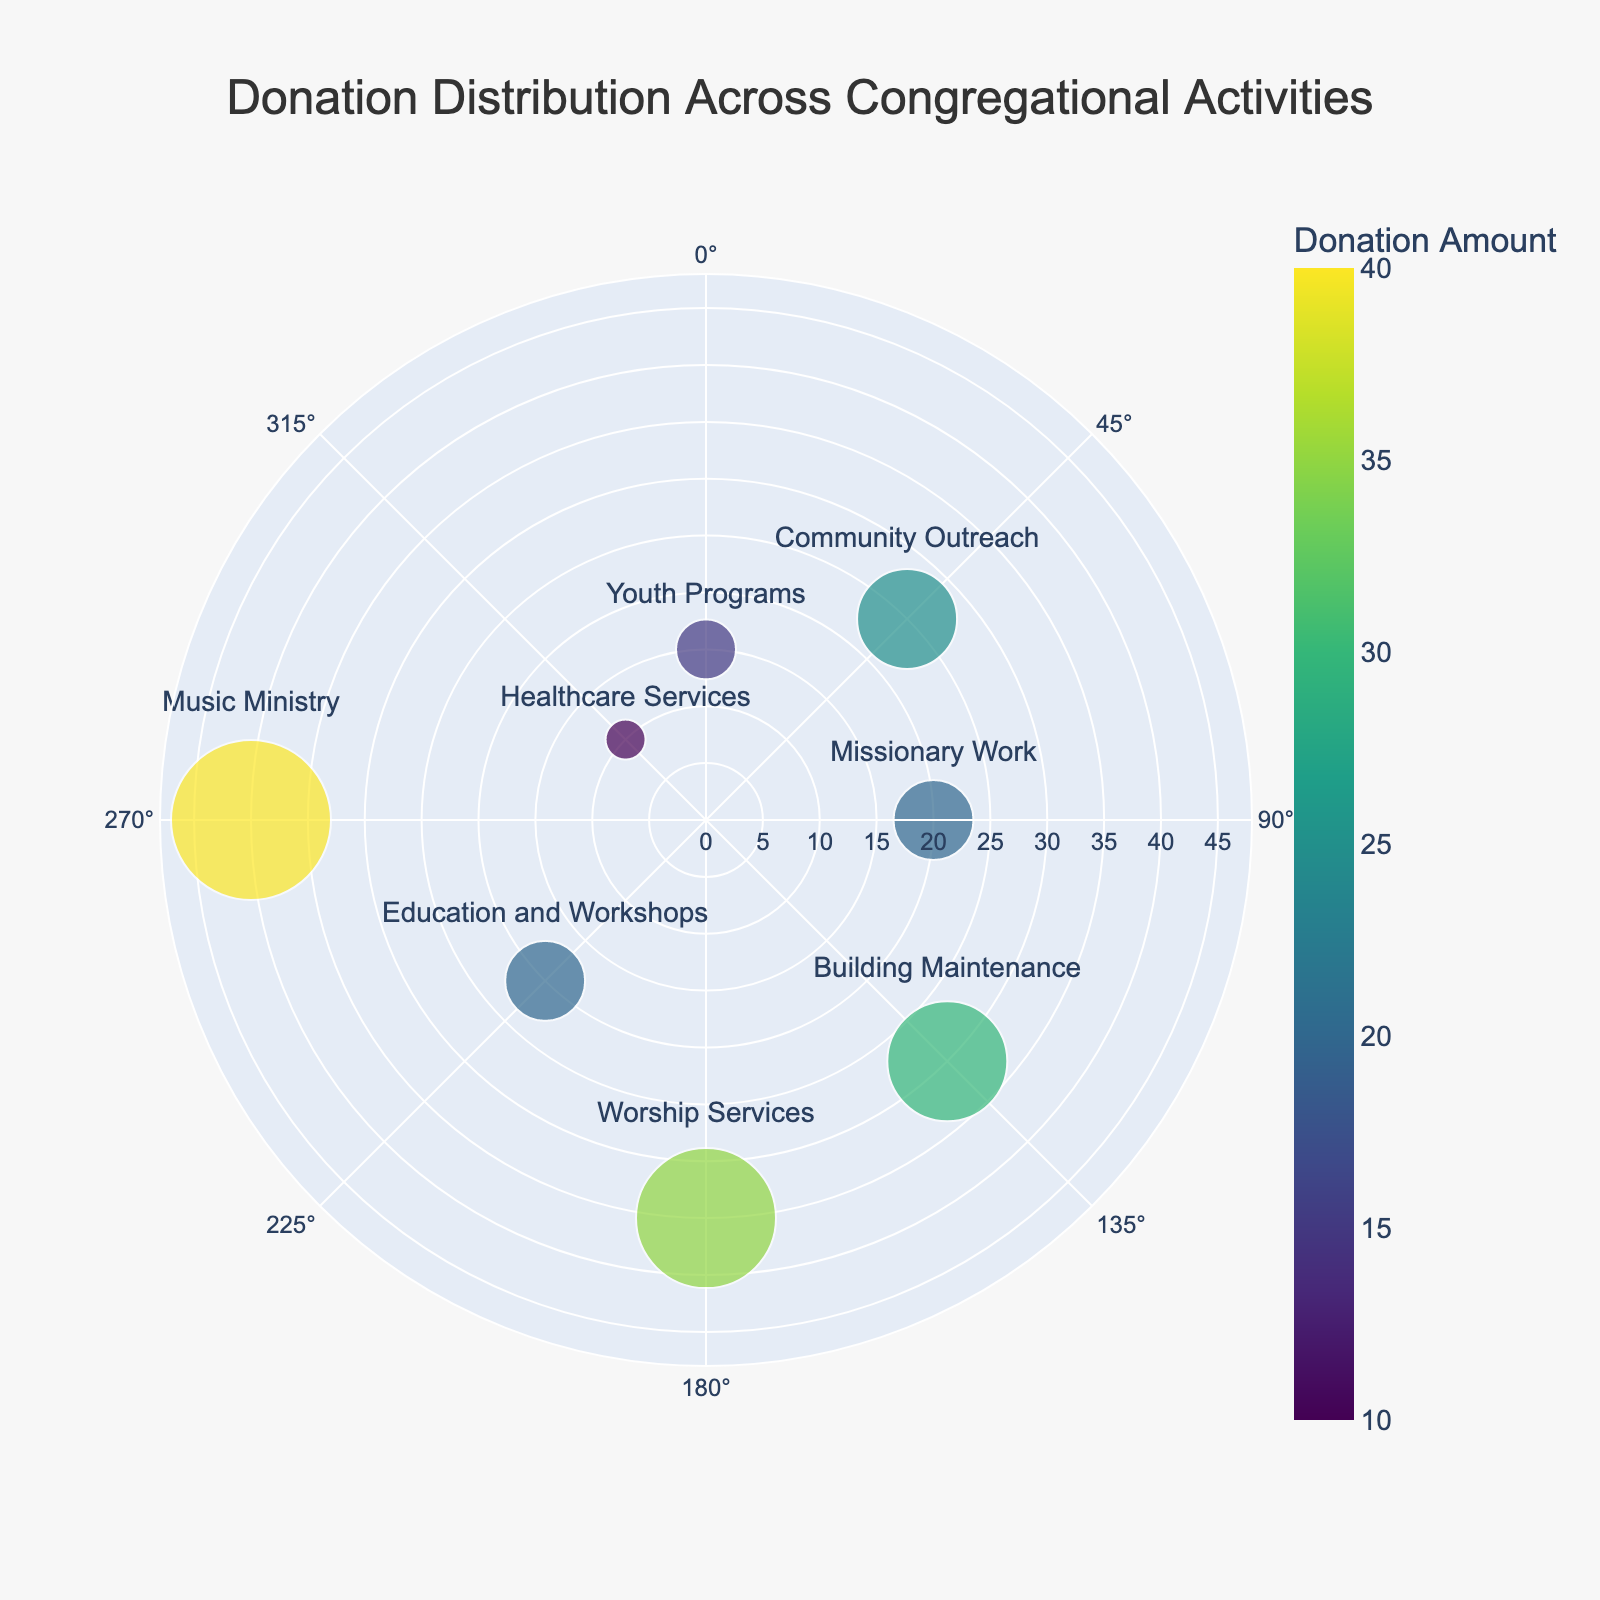What is the title of the chart? The title of the chart is written at the top center of the plot. It gives a brief overview of what the chart represents. In this case, the title explicitly states what the data is about.
Answer: Donation Distribution Across Congregational Activities How many activities have a donation amount greater than 20? First, identify the 'Distance' values greater than 20. Activities that fall under this criterion include those with distances of 25, 30, 35, and 40. Count these activities.
Answer: 4 What activity received the highest donation amount? Look for the activity with the largest marker or the highest 'Distance' value. The 'Music Ministry' has the largest distance value of 40.
Answer: Music Ministry Which two activities have the smallest donations? Identify activities with the smallest 'Distance' values. Youth Programs and Healthcare Services have the smallest distances of 15 and 10, respectively.
Answer: Youth Programs and Healthcare Services What is the difference in the donation amounts between Worship Services and Healthcare Services? Locate the 'Distance' values for Worship Services (35) and Healthcare Services (10). Subtract the smaller value from the larger value (35 - 10).
Answer: 25 What are the angular positions of Community Outreach and Building Maintenance? Locate the 'Direction' values for Community Outreach (45 degrees) and Building Maintenance (135 degrees). These angles are given directly in the chart.
Answer: 45 degrees and 135 degrees Which activity is directly opposite to Education and Workshops on the polar chart? In a polar chart, an activity directly opposite can be found by adding 180 degrees to the given direction. Education and Workshops are at 225 degrees. Adding 180 degrees gives 405 degrees, which is equivalent to 45 degrees (0–360 range). Hence, Community Outreach is directly opposite.
Answer: Community Outreach What is the total donation amount for Youth Programs, Missionary Work, and Music Ministry combined? Sum the 'Distance' values of these activities. Youth Programs (15), Missionary Work (20), and Music Ministry (40). Calculate the total (15 + 20 + 40).
Answer: 75 Which quadrant has the most activities with donations over 20? Quadrants can be defined by their angular ranges (0-90, 90-180, 180-270, 270-360). Identify activities with 'Distance' over 20 and count them in each quadrant: Community Outreach (1st), Missionary Work & Worship Services (2nd), and Music Ministry (4th). 2nd quadrant has the most activities.
Answer: Second quadrant What is the average donation amount across all activities? Sum all 'Distance' values and divide by the number of activities. The total sum is (15 + 25 + 20 + 30 + 35 + 20 + 40 + 10) = 195. Divide by the number of activities (8).
Answer: 24.375 